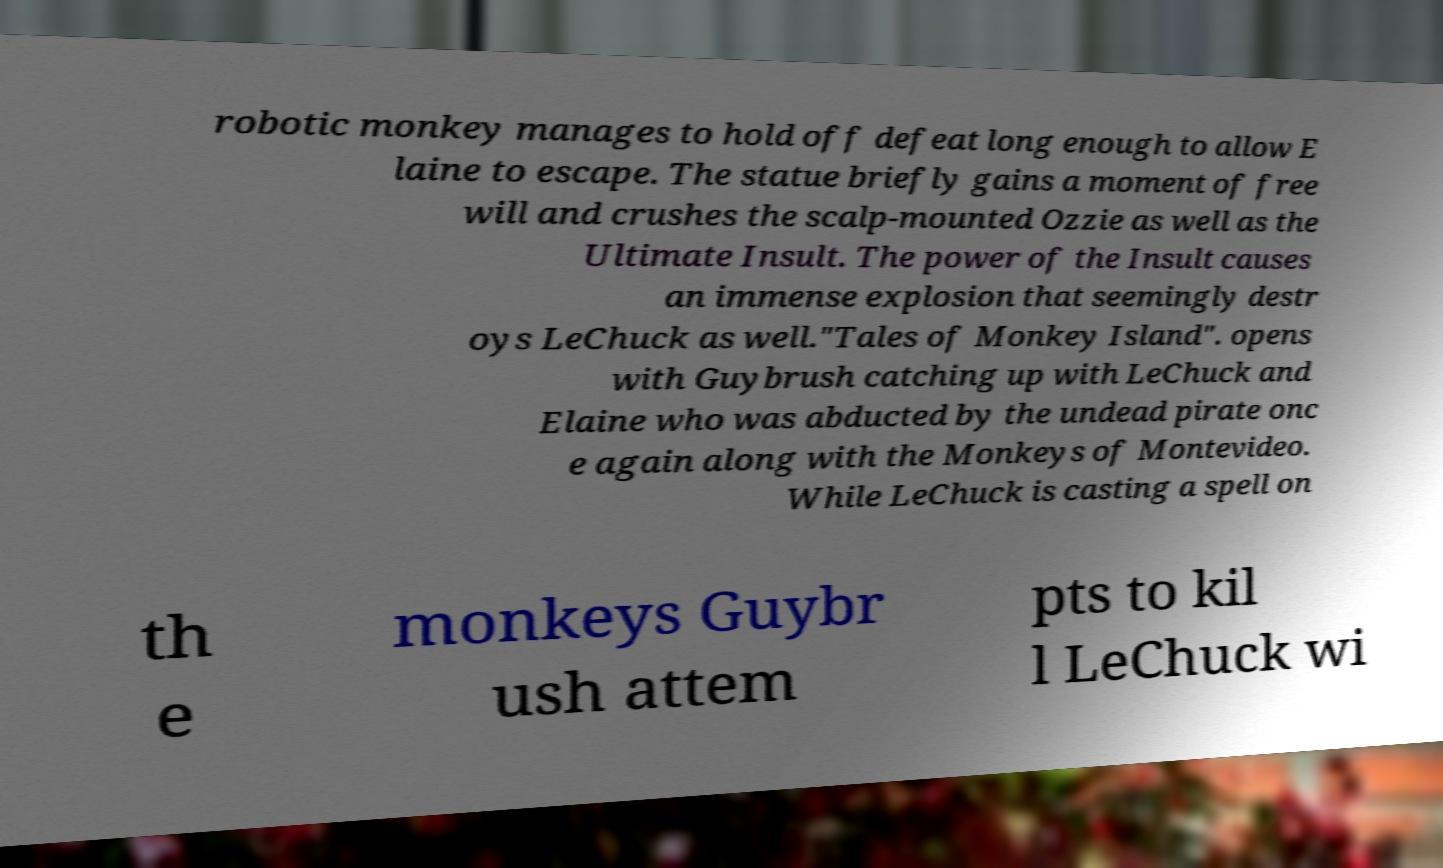I need the written content from this picture converted into text. Can you do that? robotic monkey manages to hold off defeat long enough to allow E laine to escape. The statue briefly gains a moment of free will and crushes the scalp-mounted Ozzie as well as the Ultimate Insult. The power of the Insult causes an immense explosion that seemingly destr oys LeChuck as well."Tales of Monkey Island". opens with Guybrush catching up with LeChuck and Elaine who was abducted by the undead pirate onc e again along with the Monkeys of Montevideo. While LeChuck is casting a spell on th e monkeys Guybr ush attem pts to kil l LeChuck wi 